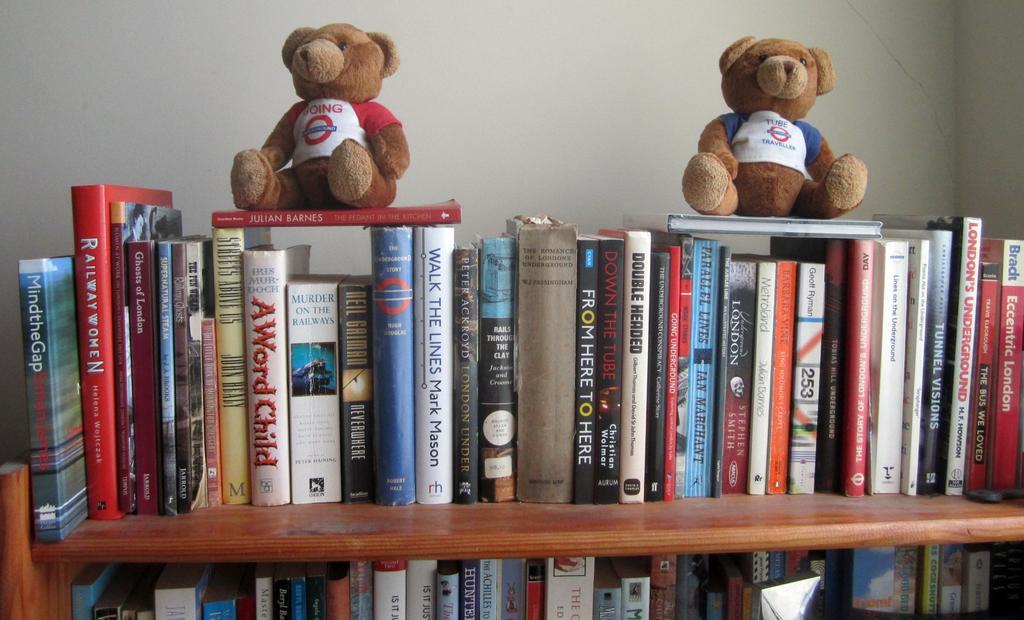Please provide a concise description of this image. In this image, there are two teddy bears and books on a rack. In the background, there is a wall. 